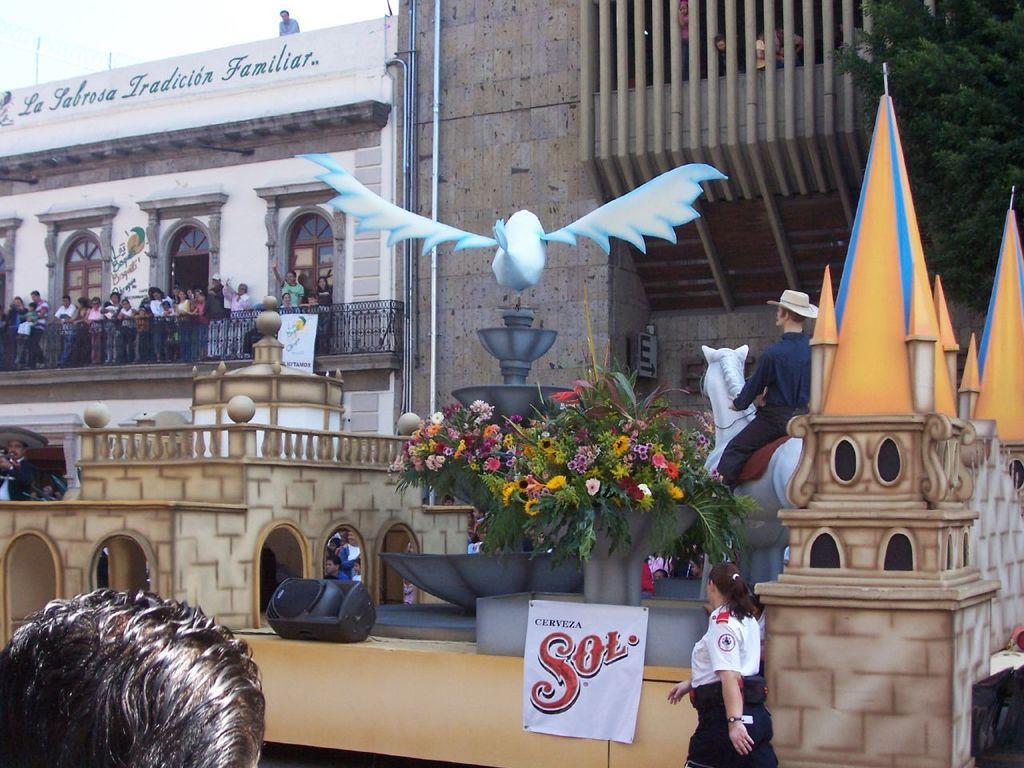In one or two sentences, can you explain what this image depicts? At the bottom, we see the woman is walking on the road. Beside her, we see a board in white color with some text written on it. Beside her, we see flower pots and the statue of the man riding the horse and we even see the statue of the bird. On the left side, we see a building in white color and people are standing. In front of them, we see iron railing. There are buildings and trees in the background. 